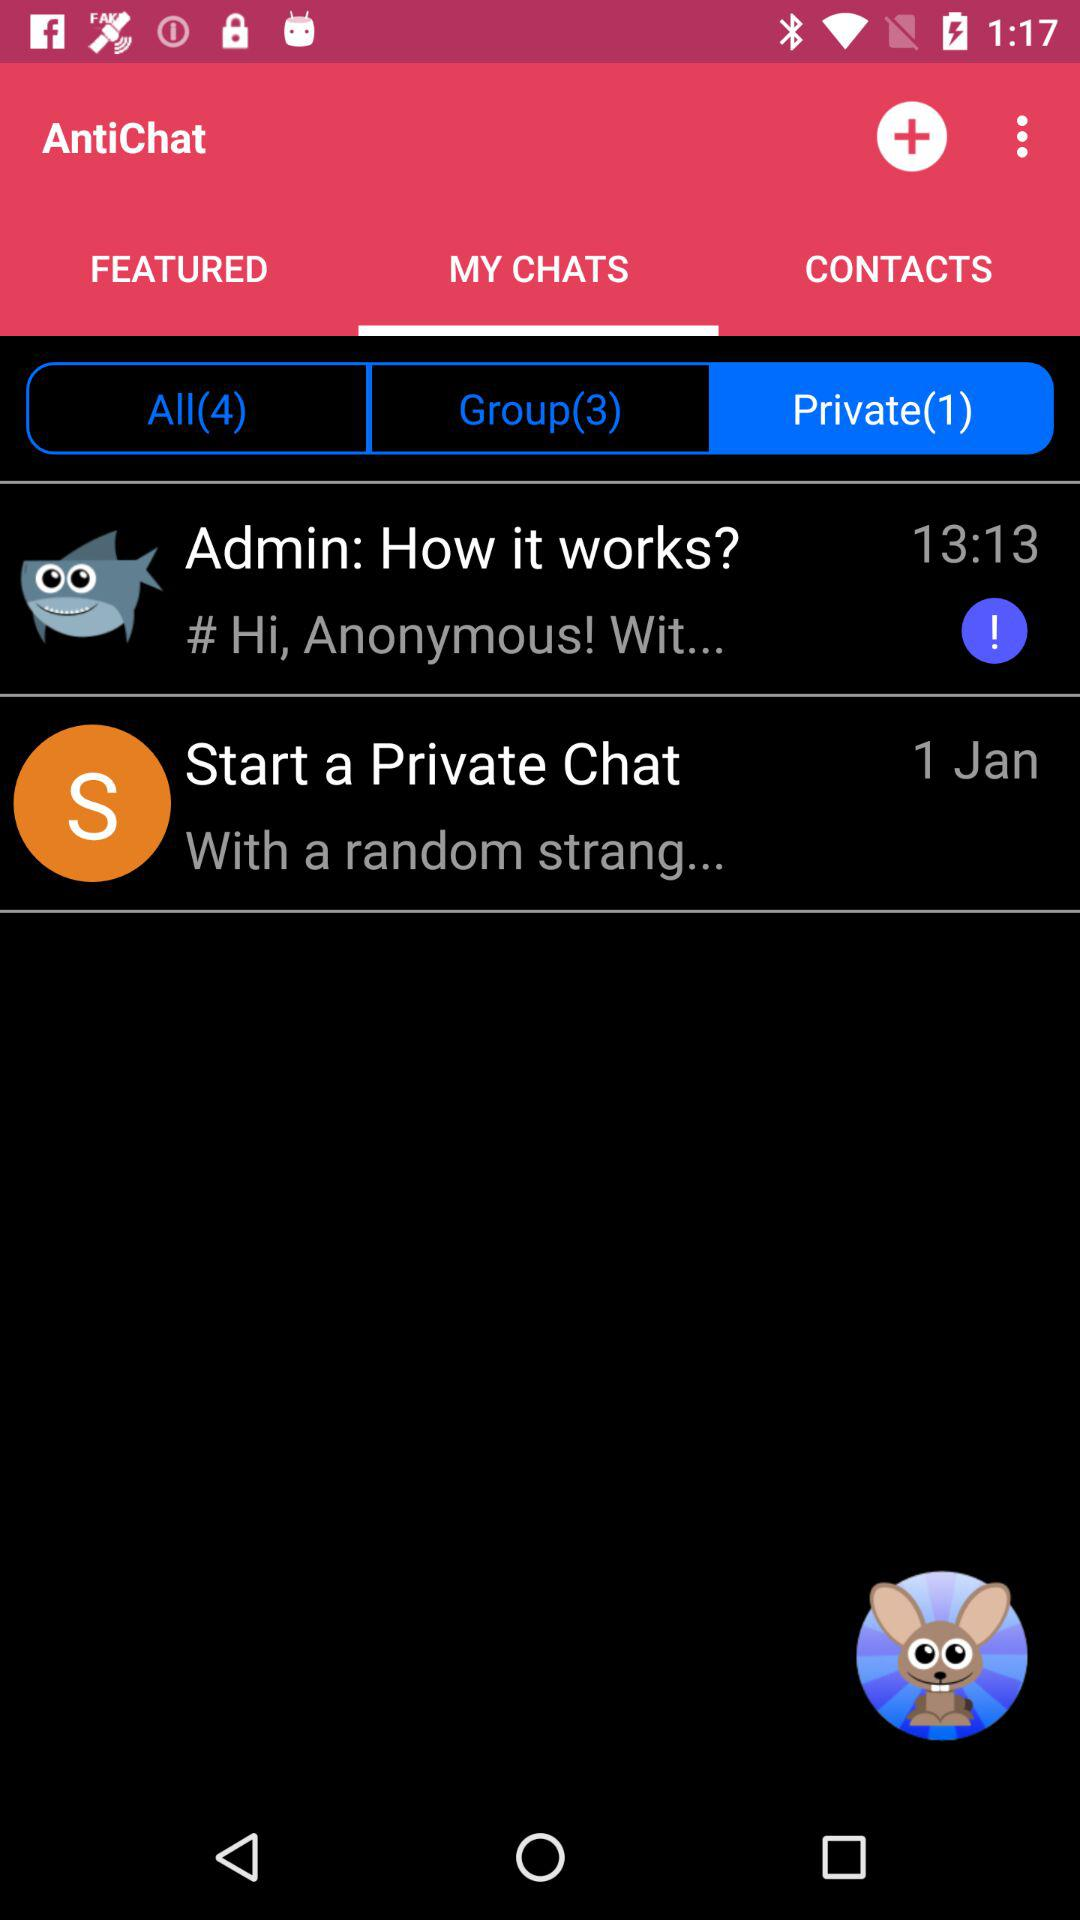How many messages are in the private conversation?
Answer the question using a single word or phrase. 1 